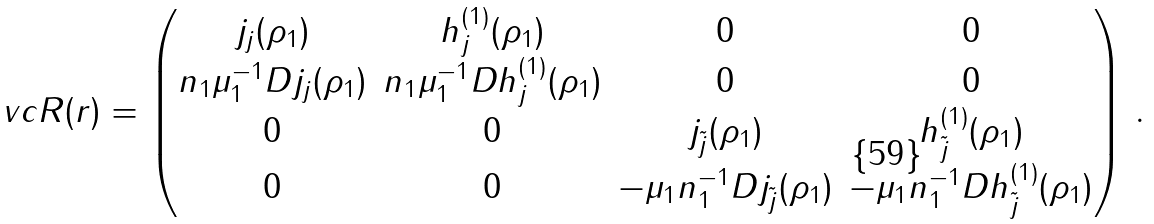Convert formula to latex. <formula><loc_0><loc_0><loc_500><loc_500>\ v c { R } ( r ) = \begin{pmatrix} j _ { j } ( \rho _ { 1 } ) & h _ { j } ^ { ( 1 ) } ( \rho _ { 1 } ) & 0 & 0 \\ n _ { 1 } \mu _ { 1 } ^ { - 1 } D j _ { j } ( \rho _ { 1 } ) & n _ { 1 } \mu _ { 1 } ^ { - 1 } D h _ { j } ^ { ( 1 ) } ( \rho _ { 1 } ) & 0 & 0 \\ 0 & 0 & j _ { \tilde { j } } ( \rho _ { 1 } ) & h _ { \tilde { j } } ^ { ( 1 ) } ( \rho _ { 1 } ) \\ 0 & 0 & - \mu _ { 1 } n _ { 1 } ^ { - 1 } D j _ { \tilde { j } } ( \rho _ { 1 } ) & - \mu _ { 1 } n _ { 1 } ^ { - 1 } D h _ { \tilde { j } } ^ { ( 1 ) } ( \rho _ { 1 } ) \\ \end{pmatrix} \, .</formula> 